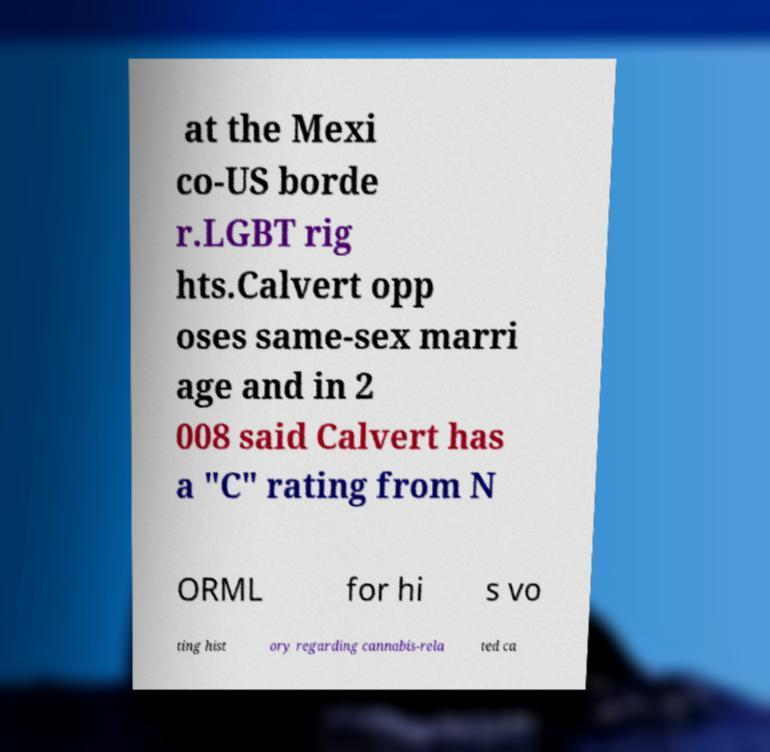What messages or text are displayed in this image? I need them in a readable, typed format. at the Mexi co-US borde r.LGBT rig hts.Calvert opp oses same-sex marri age and in 2 008 said Calvert has a "C" rating from N ORML for hi s vo ting hist ory regarding cannabis-rela ted ca 